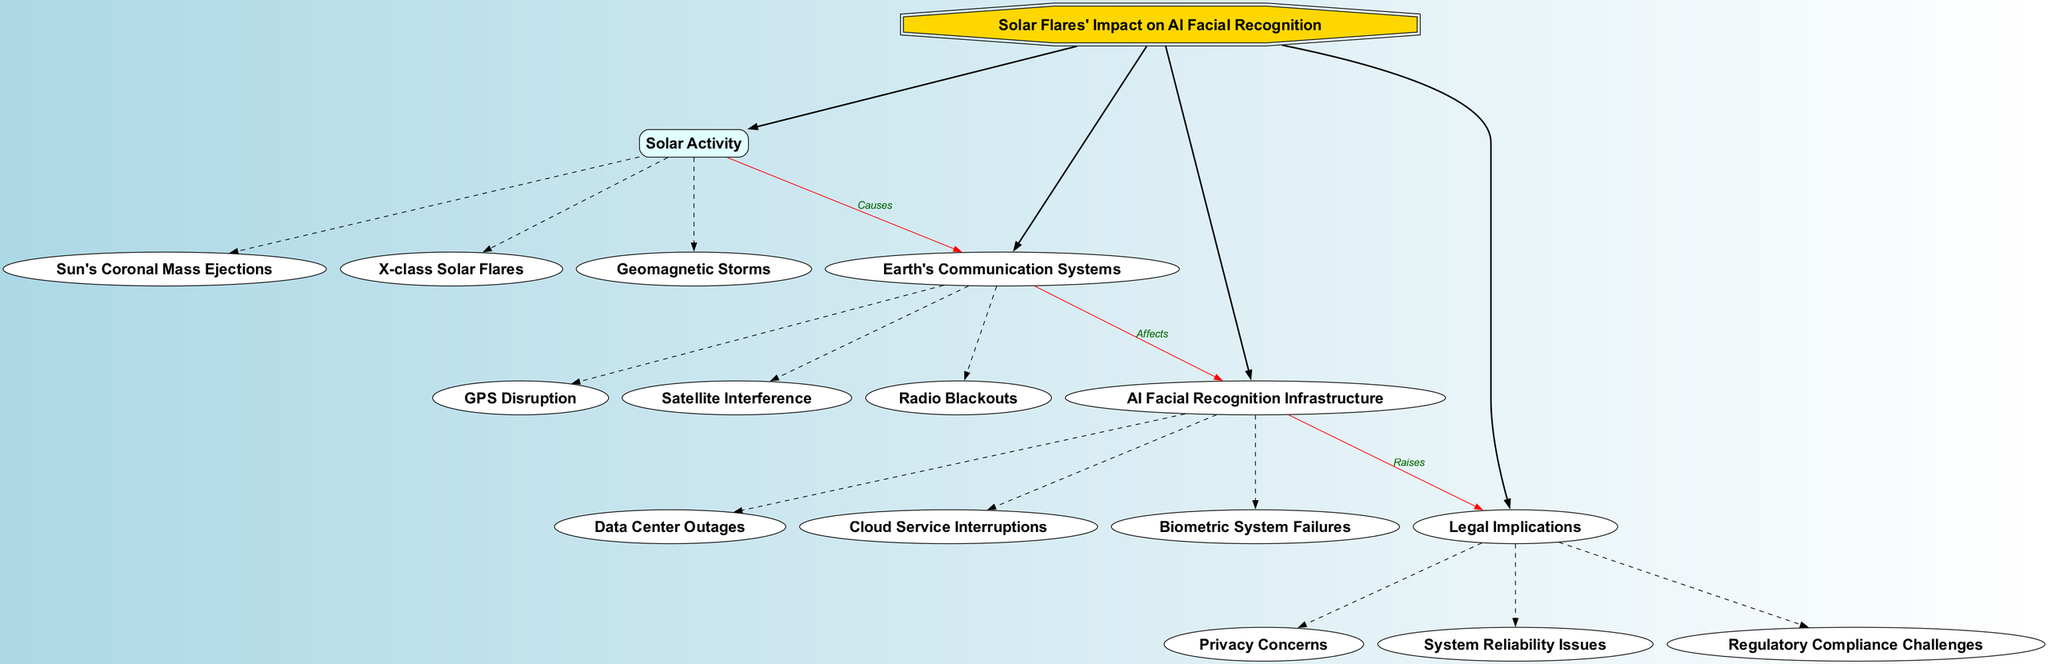What is the central topic of the diagram? The central topic is the main title of the diagram, clearly labeled in a prominent shape. Therefore, by looking at that part, we can easily determine that it discusses the "Solar Flares' Impact on AI Facial Recognition."
Answer: Solar Flares' Impact on AI Facial Recognition How many main branches are there in the diagram? The main branches stem directly from the central node. By counting the distinct branches connected to the central topic, we find there are four main branches: Solar Activity, Earth's Communication Systems, AI Facial Recognition Infrastructure, and Legal Implications.
Answer: 4 What does Solar Activity cause according to the diagram? The connection from the Solar Activity branch to the Earth's Communication Systems is labeled "Causes." This clearly indicates that Solar Activity causes disruptions in the Earth's Communication Systems.
Answer: Earth's Communication Systems Which subbranch is linked to AI Facial Recognition Infrastructure? Looking at the connections leading into the AI Facial Recognition Infrastructure branch, all subbranches are connected to it. However, the diagram specifically outlines that it directly includes subbranches such as Data Center Outages, Cloud Service Interruptions, and Biometric System Failures.
Answer: Data Center Outages What are the connections between Earth's Communication Systems and AI Facial Recognition Infrastructure? The connection from Earth's Communication Systems to AI Facial Recognition Infrastructure is labeled "Affects." This suggests that any issues related to Earth's Communication Systems influence or disrupt AI Facial Recognition Infrastructure.
Answer: Affects What legal implications arise from AI Facial Recognition Infrastructure failures? The diagram indicates a direct connection from AI Facial Recognition Infrastructure to Legal Implications, marked as "Raises." This suggests that issues in AI Facial Recognition can lead to concerns regarding privacy, system reliability, and regulatory compliance challenges.
Answer: Privacy Concerns How does solar activity relate to legal implications in the diagram? To understand this relationship, we must trace the connections: Solar Activity causes disruptions in Earth's Communication Systems, which then affect the AI Facial Recognition Infrastructure, finally raising various Legal Implications. This multi-step linkage shows that solar activity indirectly leads to legal concerns through its impact on technology.
Answer: Raises What type of solar activity is labeled in the diagram? The diagram lists specific types of solar activity, including Sun's Coronal Mass Ejections, X-class Solar Flares, and Geomagnetic Storms as its subbranches.
Answer: Sun's Coronal Mass Ejections How do geomagnetic storms affect communication systems? The connection labeled "Causes" between Solar Activity and Earth's Communication Systems indicates that geomagnetic storms, as a type of solar activity, directly disrupt communications. This can include various forms of interference.
Answer: GPS Disruption What are the subbranches under Legal Implications? The Legal Implications branch contains subbranches including Privacy Concerns, System Reliability Issues, and Regulatory Compliance Challenges. By identifying these items under the corresponding branch, we can clearly list these legal concerns.
Answer: Privacy Concerns, System Reliability Issues, Regulatory Compliance Challenges 